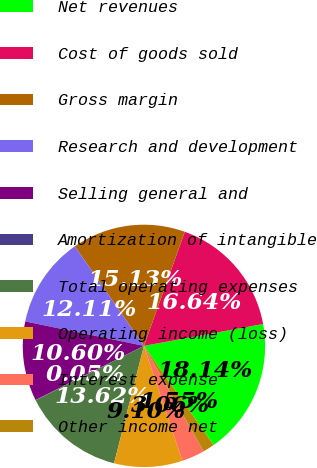Convert chart to OTSL. <chart><loc_0><loc_0><loc_500><loc_500><pie_chart><fcel>Net revenues<fcel>Cost of goods sold<fcel>Gross margin<fcel>Research and development<fcel>Selling general and<fcel>Amortization of intangible<fcel>Total operating expenses<fcel>Operating income (loss)<fcel>Interest expense<fcel>Other income net<nl><fcel>18.14%<fcel>16.64%<fcel>15.13%<fcel>12.11%<fcel>10.6%<fcel>0.05%<fcel>13.62%<fcel>9.1%<fcel>3.06%<fcel>1.55%<nl></chart> 